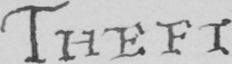Transcribe the text shown in this historical manuscript line. THEFT 